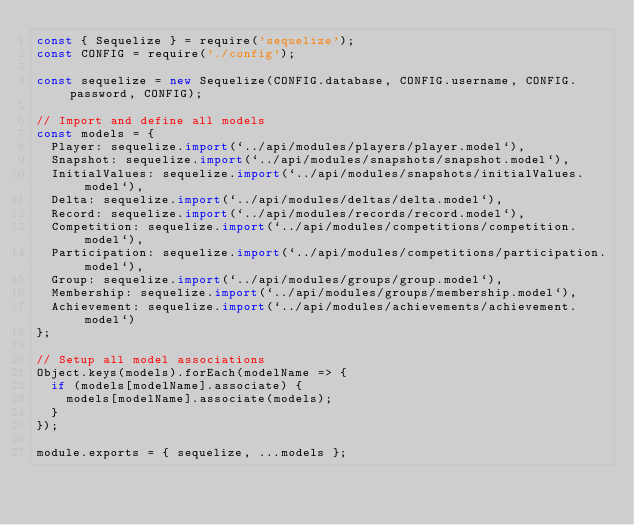<code> <loc_0><loc_0><loc_500><loc_500><_JavaScript_>const { Sequelize } = require('sequelize');
const CONFIG = require('./config');

const sequelize = new Sequelize(CONFIG.database, CONFIG.username, CONFIG.password, CONFIG);

// Import and define all models
const models = {
  Player: sequelize.import(`../api/modules/players/player.model`),
  Snapshot: sequelize.import(`../api/modules/snapshots/snapshot.model`),
  InitialValues: sequelize.import(`../api/modules/snapshots/initialValues.model`),
  Delta: sequelize.import(`../api/modules/deltas/delta.model`),
  Record: sequelize.import(`../api/modules/records/record.model`),
  Competition: sequelize.import(`../api/modules/competitions/competition.model`),
  Participation: sequelize.import(`../api/modules/competitions/participation.model`),
  Group: sequelize.import(`../api/modules/groups/group.model`),
  Membership: sequelize.import(`../api/modules/groups/membership.model`),
  Achievement: sequelize.import(`../api/modules/achievements/achievement.model`)
};

// Setup all model associations
Object.keys(models).forEach(modelName => {
  if (models[modelName].associate) {
    models[modelName].associate(models);
  }
});

module.exports = { sequelize, ...models };
</code> 